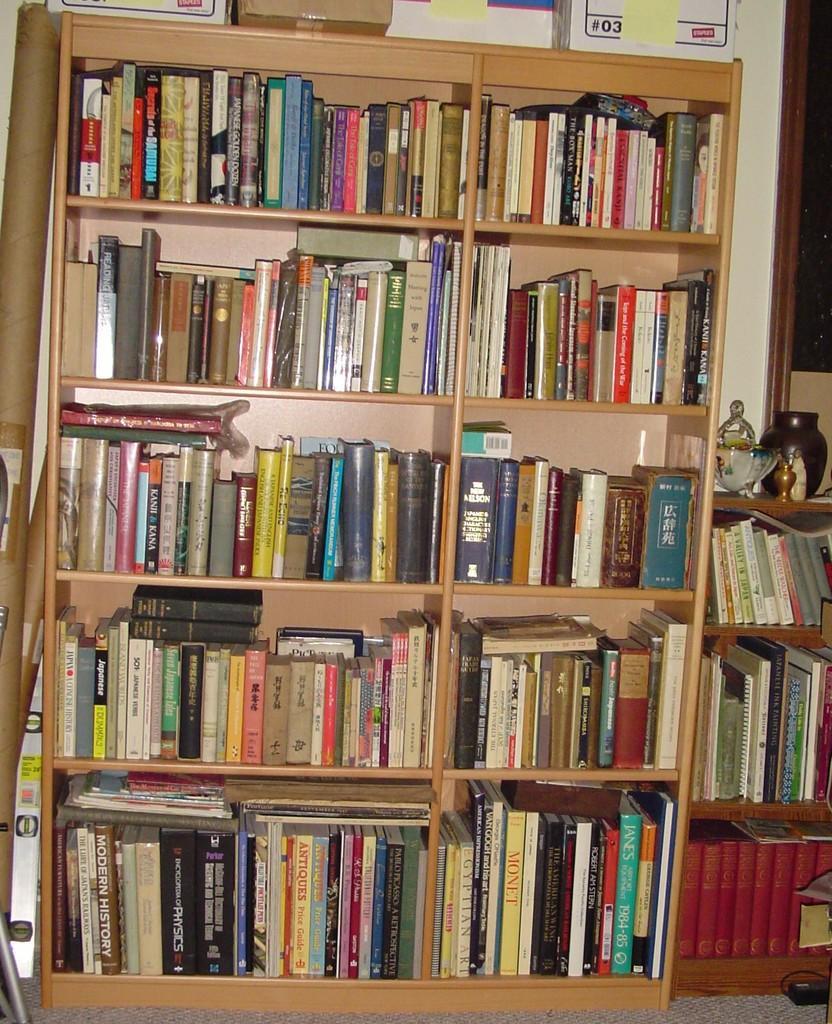How would you summarize this image in a sentence or two? In this image, we can see wooden shelves. On the racks, so many books are placed. On the right side and left side of the image, we can see few objects. Background we can see wall, poster and few boxes. At the bottom, there is a floor. 